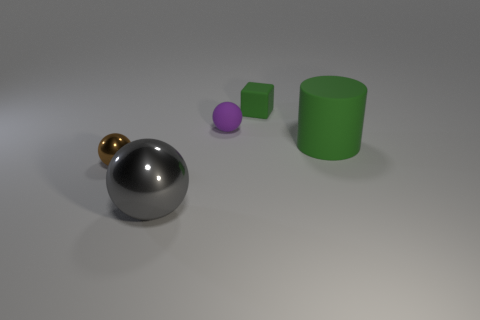How would you describe the arrangement and colors of the objects in the image? The image shows a collection of objects arranged on a flat surface with a gentle gradient of light. There is a large gray metallic sphere, a smaller golden sphere, a muted purple rubber ball, a small green cube, and a larger green cylinder. The objects are arranged in a slightly scattered manner, creating a visual contrast with their varying colors and materials. 